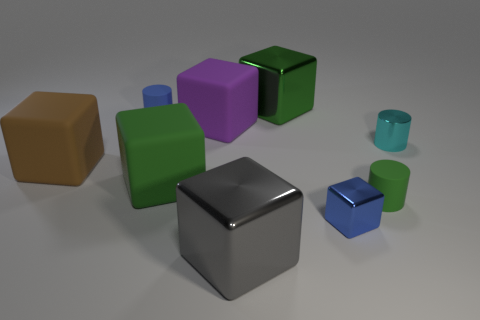Subtract all green blocks. How many blocks are left? 4 Subtract all blue cubes. How many cubes are left? 5 Subtract all purple cubes. Subtract all red cylinders. How many cubes are left? 5 Add 1 tiny blue cylinders. How many objects exist? 10 Subtract all cubes. How many objects are left? 3 Subtract all cylinders. Subtract all gray shiny cubes. How many objects are left? 5 Add 6 tiny cylinders. How many tiny cylinders are left? 9 Add 2 cyan rubber spheres. How many cyan rubber spheres exist? 2 Subtract 0 red cubes. How many objects are left? 9 